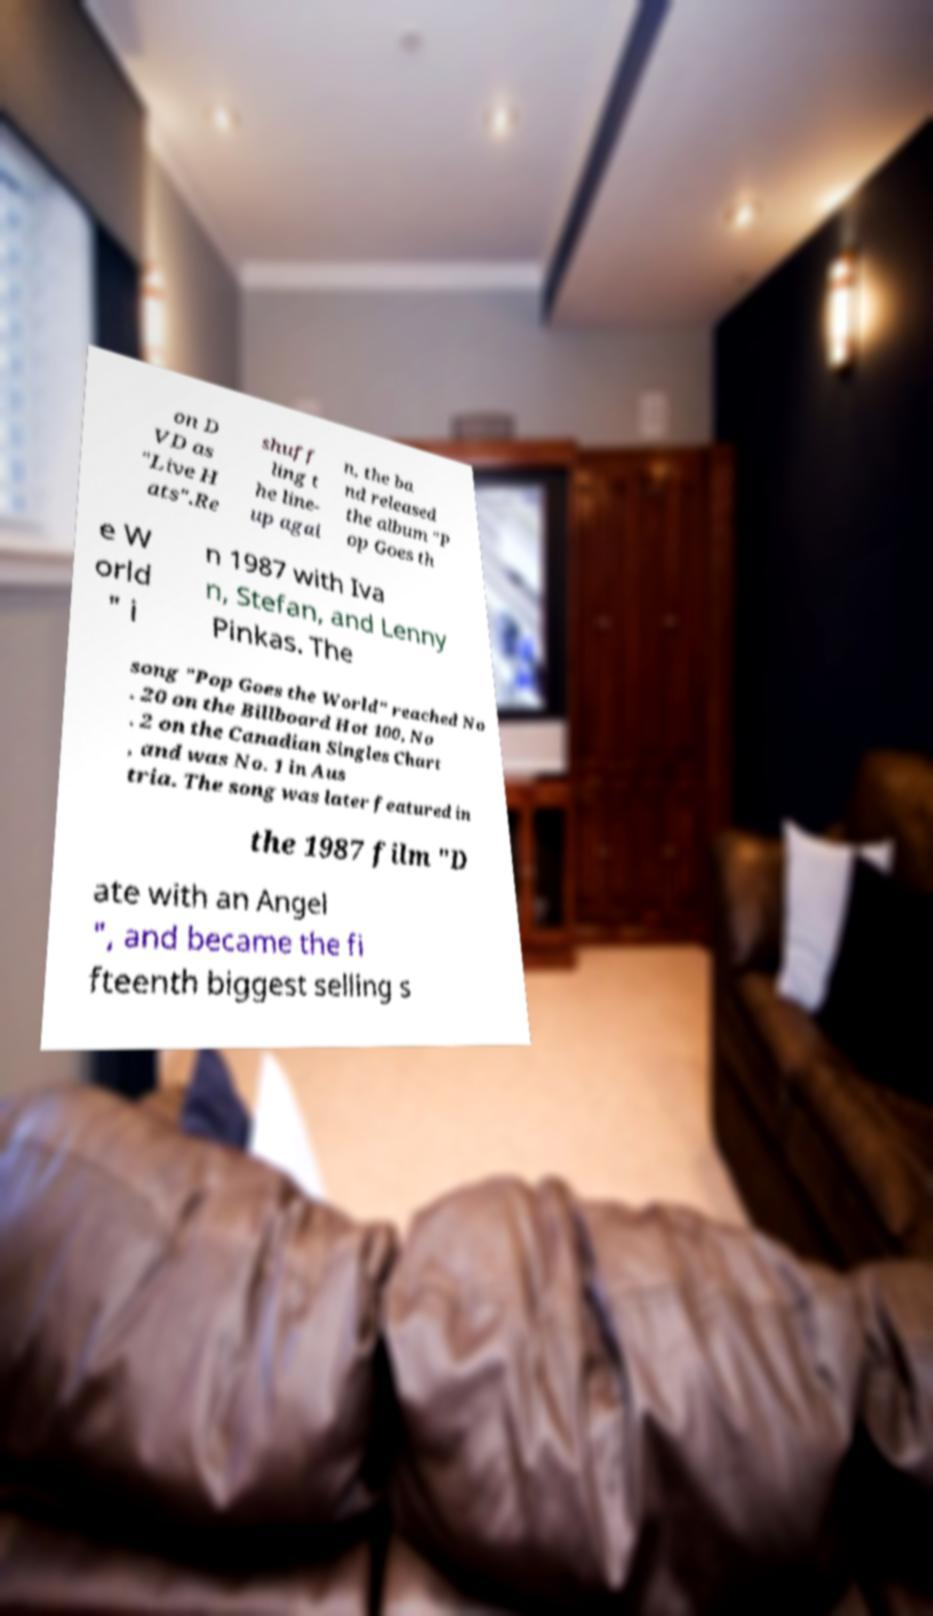There's text embedded in this image that I need extracted. Can you transcribe it verbatim? on D VD as "Live H ats".Re shuff ling t he line- up agai n, the ba nd released the album "P op Goes th e W orld " i n 1987 with Iva n, Stefan, and Lenny Pinkas. The song "Pop Goes the World" reached No . 20 on the Billboard Hot 100, No . 2 on the Canadian Singles Chart , and was No. 1 in Aus tria. The song was later featured in the 1987 film "D ate with an Angel ", and became the fi fteenth biggest selling s 